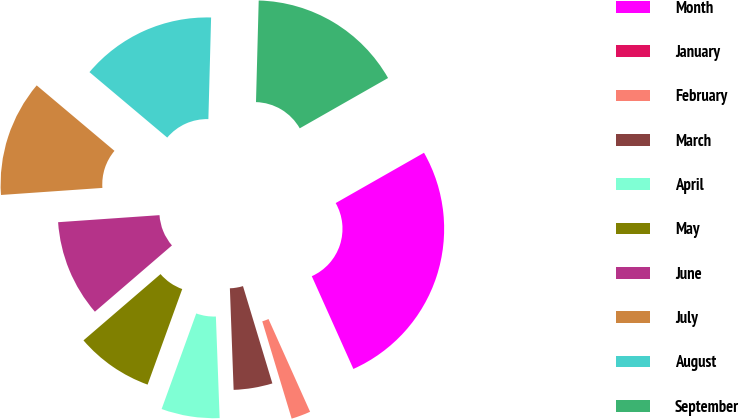Convert chart. <chart><loc_0><loc_0><loc_500><loc_500><pie_chart><fcel>Month<fcel>January<fcel>February<fcel>March<fcel>April<fcel>May<fcel>June<fcel>July<fcel>August<fcel>September<nl><fcel>26.53%<fcel>0.0%<fcel>2.04%<fcel>4.08%<fcel>6.12%<fcel>8.16%<fcel>10.2%<fcel>12.24%<fcel>14.29%<fcel>16.33%<nl></chart> 